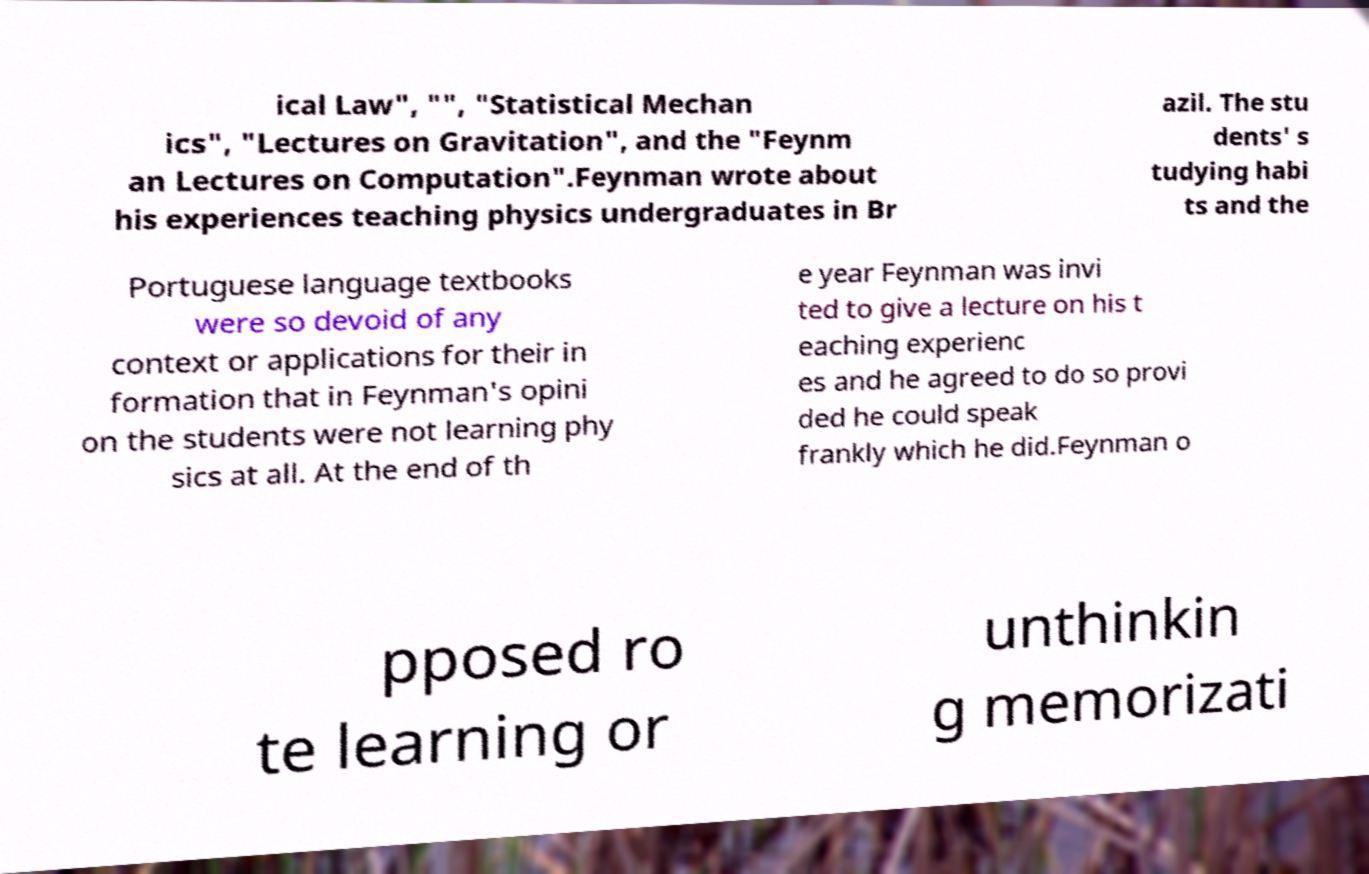I need the written content from this picture converted into text. Can you do that? ical Law", "", "Statistical Mechan ics", "Lectures on Gravitation", and the "Feynm an Lectures on Computation".Feynman wrote about his experiences teaching physics undergraduates in Br azil. The stu dents' s tudying habi ts and the Portuguese language textbooks were so devoid of any context or applications for their in formation that in Feynman's opini on the students were not learning phy sics at all. At the end of th e year Feynman was invi ted to give a lecture on his t eaching experienc es and he agreed to do so provi ded he could speak frankly which he did.Feynman o pposed ro te learning or unthinkin g memorizati 